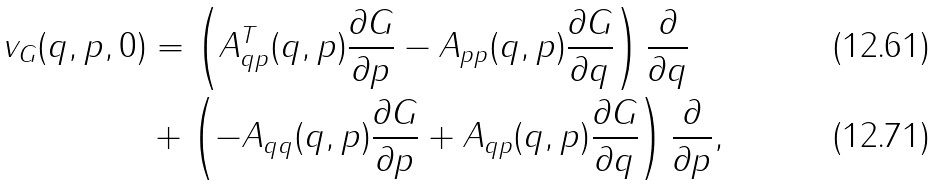<formula> <loc_0><loc_0><loc_500><loc_500>{ v } _ { G } ( q , p , 0 ) & = \left ( A _ { q p } ^ { T } ( { q , p } ) \frac { \partial G } { \partial p } - A _ { p p } ( { q , p } ) \frac { \partial G } { \partial q } \right ) \frac { \partial } { \partial q } \\ & + \left ( - A _ { q q } ( { q , p } ) \frac { \partial G } { \partial p } + A _ { q p } ( q , p ) \frac { \partial G } { \partial q } \right ) \frac { \partial } { \partial p } ,</formula> 